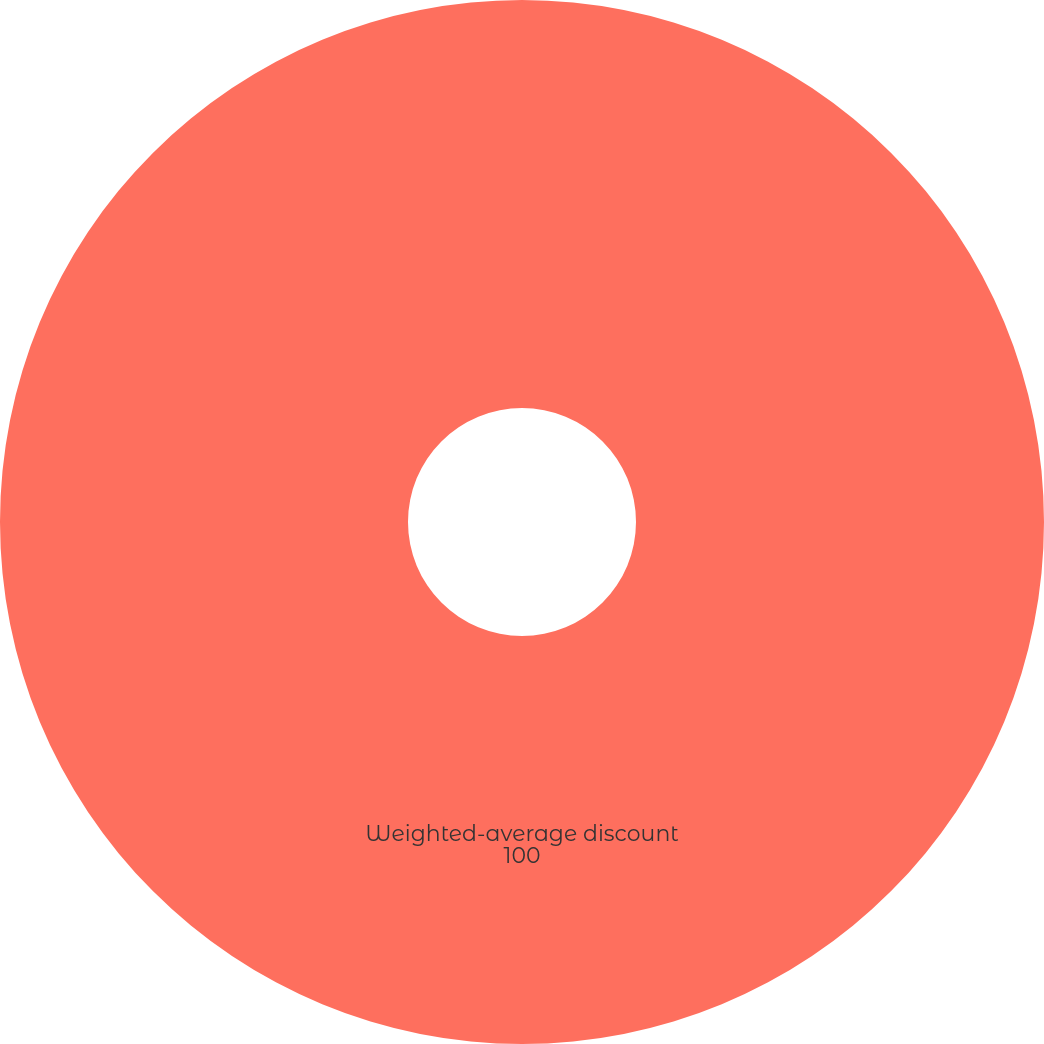Convert chart to OTSL. <chart><loc_0><loc_0><loc_500><loc_500><pie_chart><fcel>Weighted-average discount<nl><fcel>100.0%<nl></chart> 